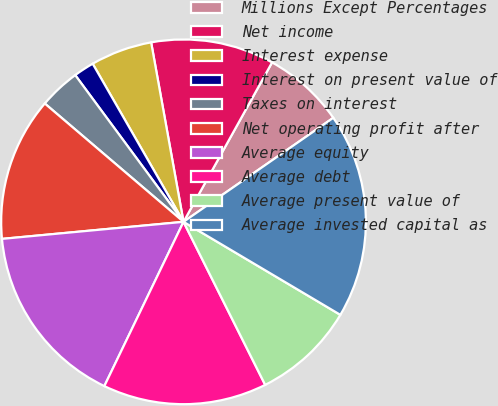<chart> <loc_0><loc_0><loc_500><loc_500><pie_chart><fcel>Millions Except Percentages<fcel>Net income<fcel>Interest expense<fcel>Interest on present value of<fcel>Taxes on interest<fcel>Net operating profit after<fcel>Average equity<fcel>Average debt<fcel>Average present value of<fcel>Average invested capital as<nl><fcel>7.27%<fcel>10.91%<fcel>5.46%<fcel>1.82%<fcel>3.64%<fcel>12.73%<fcel>16.36%<fcel>14.54%<fcel>9.09%<fcel>18.18%<nl></chart> 